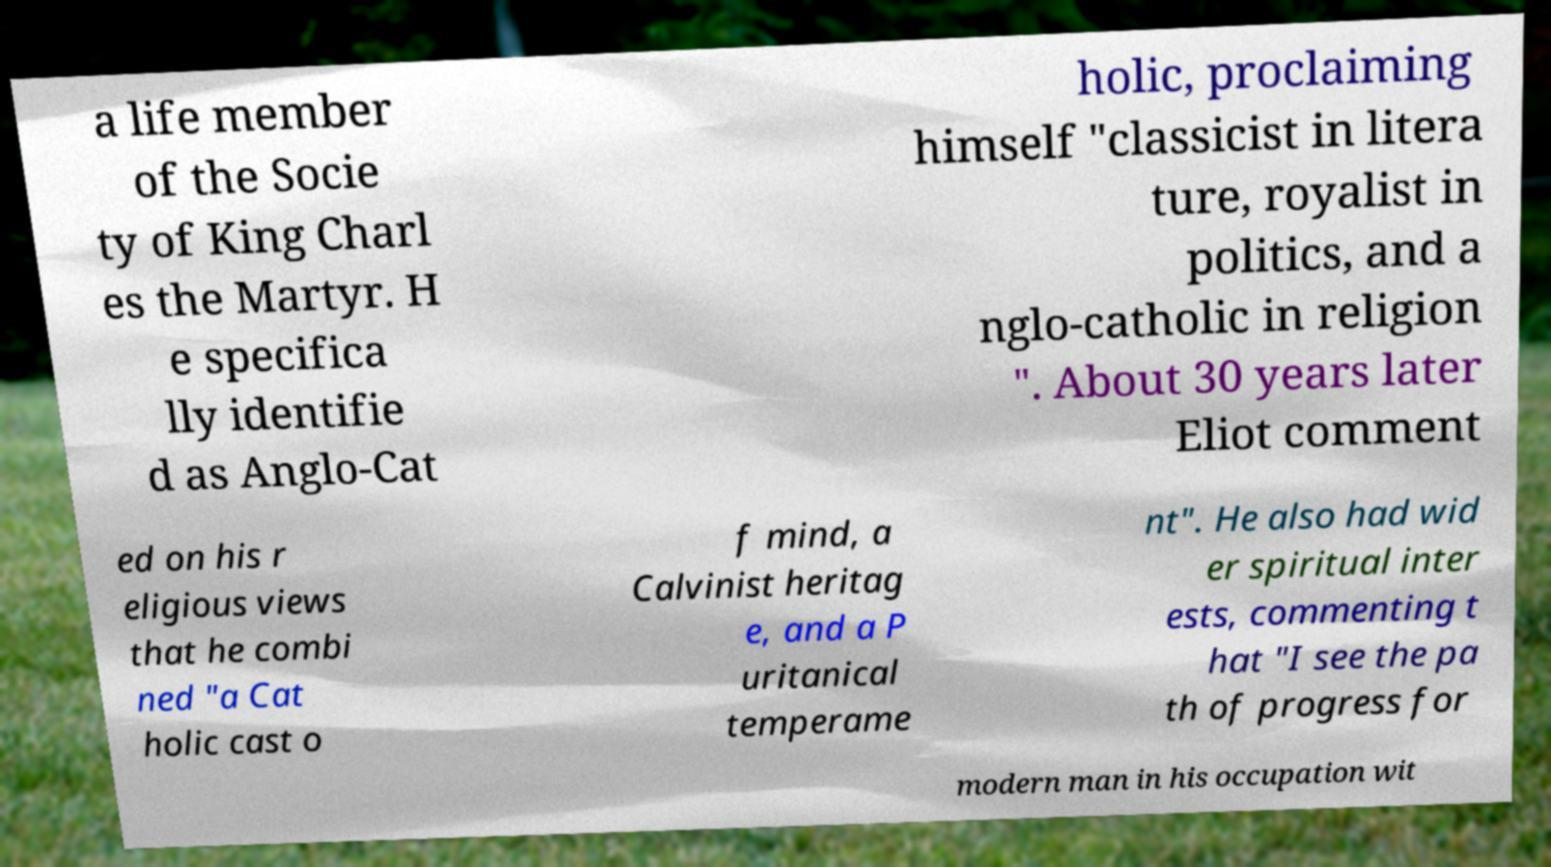Please identify and transcribe the text found in this image. a life member of the Socie ty of King Charl es the Martyr. H e specifica lly identifie d as Anglo-Cat holic, proclaiming himself "classicist in litera ture, royalist in politics, and a nglo-catholic in religion ". About 30 years later Eliot comment ed on his r eligious views that he combi ned "a Cat holic cast o f mind, a Calvinist heritag e, and a P uritanical temperame nt". He also had wid er spiritual inter ests, commenting t hat "I see the pa th of progress for modern man in his occupation wit 